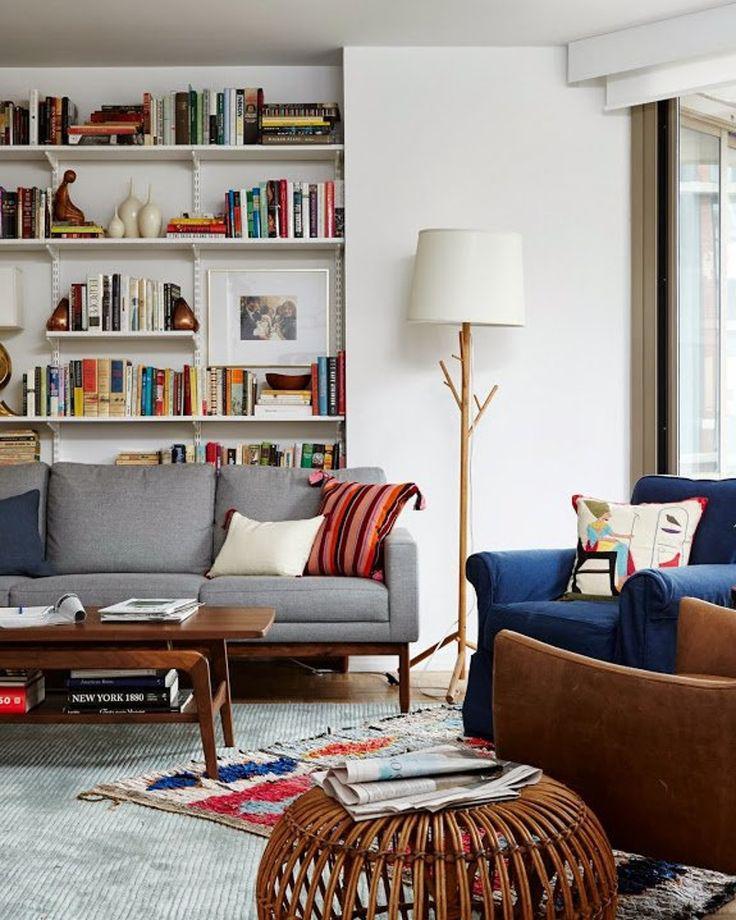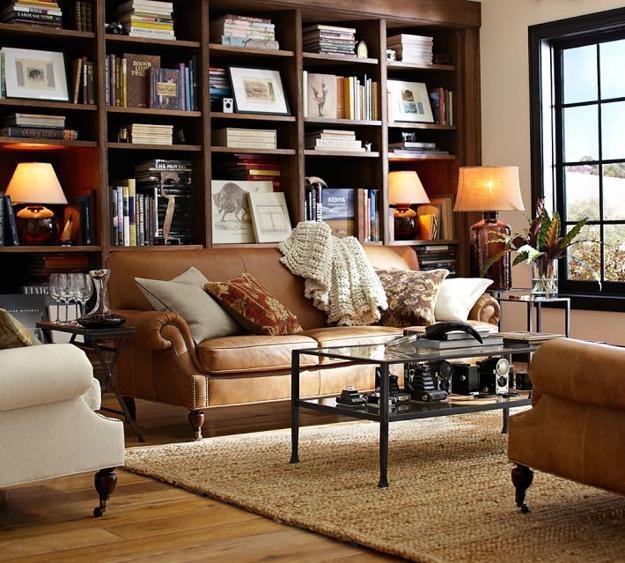The first image is the image on the left, the second image is the image on the right. Given the left and right images, does the statement "An image shows a dark sectional couch with a white pillow on one end and patterned and orange pillows on the other end." hold true? Answer yes or no. No. The first image is the image on the left, the second image is the image on the right. Given the left and right images, does the statement "In each image, a standard sized sofa with extra throw pillows and a coffee table in front of it sits parallel to a wall shelving unit." hold true? Answer yes or no. Yes. 